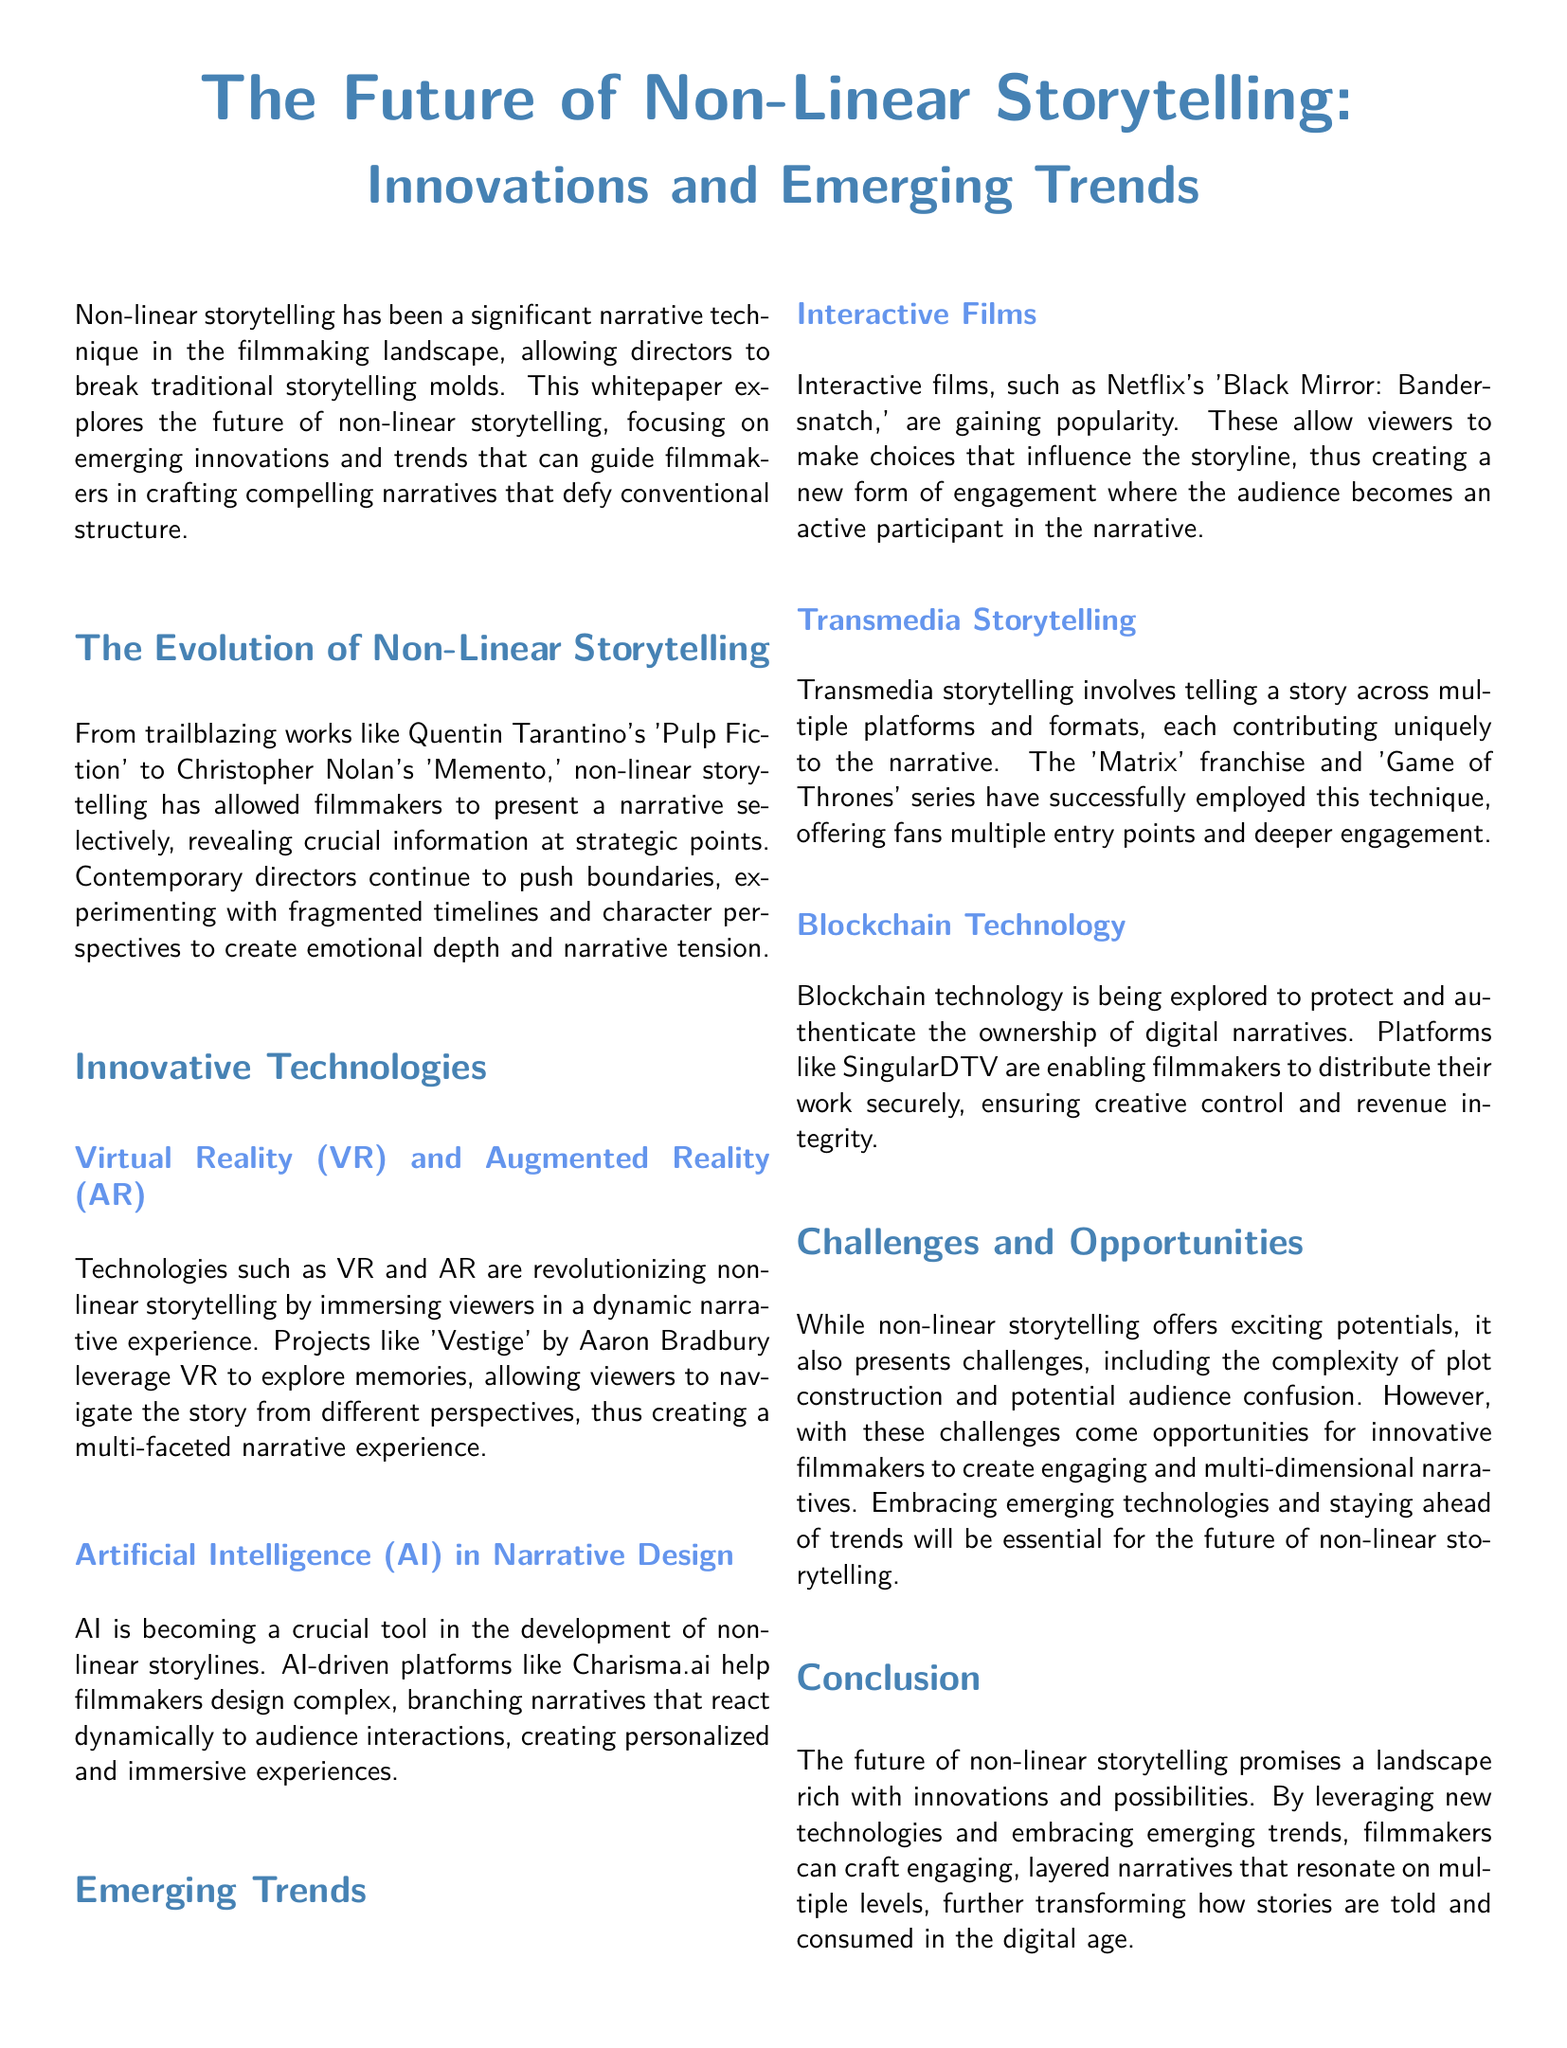What are the two innovative technologies discussed? The document lists Virtual Reality (VR) and Augmented Reality (AR) as well as Artificial Intelligence (AI) in Narrative Design as innovative technologies transforming non-linear storytelling.
Answer: Virtual Reality (VR) and Augmented Reality (AR), Artificial Intelligence (AI) Which film is mentioned as an example of an interactive film? The whitepaper provides Netflix's 'Black Mirror: Bandersnatch' as a popular example of an interactive film where viewers make choices influencing the storyline.
Answer: 'Black Mirror: Bandersnatch' What narrative technique allows stories to be told across multiple platforms? The document refers to transmedia storytelling as a technique that involves telling a story across multiple platforms and formats.
Answer: Transmedia storytelling What is one challenge of non-linear storytelling mentioned? The whitepaper discusses the complexity of plot construction as a challenge faced by filmmakers engaging in non-linear storytelling.
Answer: Complexity of plot construction What does the document suggest blockchain technology protects? The document states that blockchain technology is being explored to protect and authenticate the ownership of digital narratives.
Answer: Ownership of digital narratives How does AI enhance narrative design according to the document? The whitepaper indicates that AI-driven platforms help filmmakers design complex, branching narratives that react dynamically to audience interactions, enhancing the narrative experience.
Answer: Design complex, branching narratives What outcome does the future of non-linear storytelling promise? The conclusion emphasizes that the future promises a landscape rich with innovations and possibilities for filmmakers.
Answer: Innovations and possibilities 